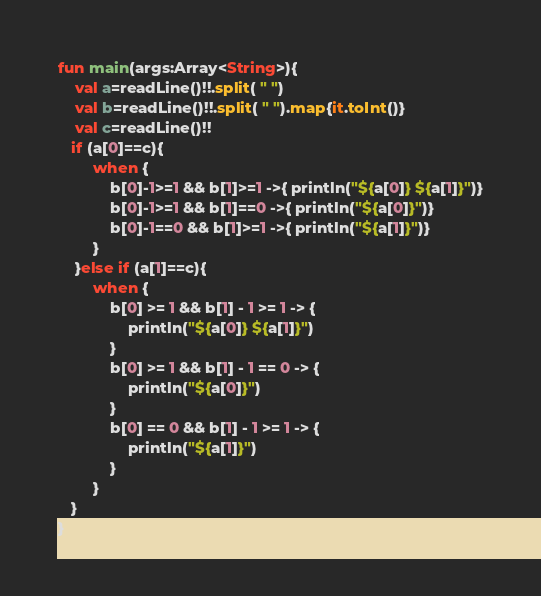Convert code to text. <code><loc_0><loc_0><loc_500><loc_500><_Kotlin_>fun main(args:Array<String>){
    val a=readLine()!!.split( " ")
    val b=readLine()!!.split( " ").map{it.toInt()}
    val c=readLine()!!
   if (a[0]==c){
        when {
            b[0]-1>=1 && b[1]>=1 ->{ println("${a[0]} ${a[1]}")}
            b[0]-1>=1 && b[1]==0 ->{ println("${a[0]}")}
            b[0]-1==0 && b[1]>=1 ->{ println("${a[1]}")}
        }
    }else if (a[1]==c){
        when {
            b[0] >= 1 && b[1] - 1 >= 1 -> {
                println("${a[0]} ${a[1]}")
            }
            b[0] >= 1 && b[1] - 1 == 0 -> {
                println("${a[0]}")
            }
            b[0] == 0 && b[1] - 1 >= 1 -> {
                println("${a[1]}")
            }
        }
   }
}</code> 